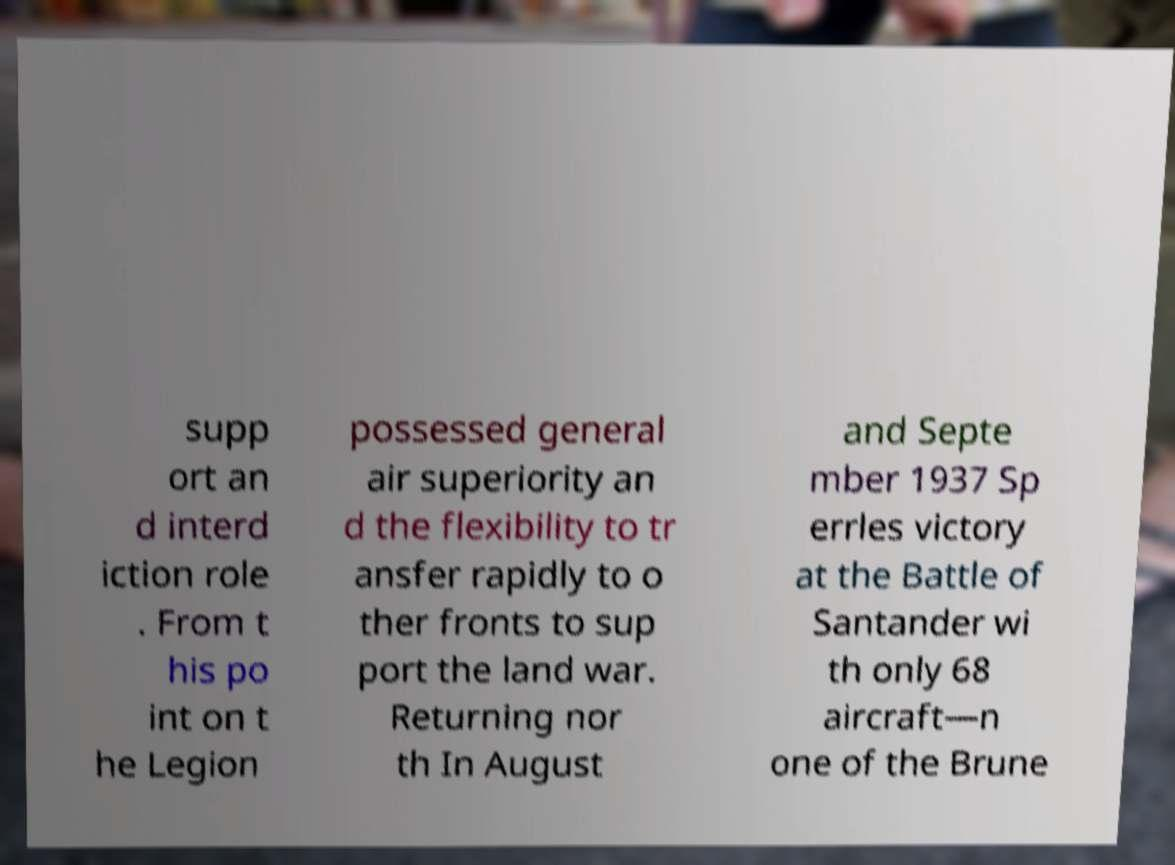Please identify and transcribe the text found in this image. supp ort an d interd iction role . From t his po int on t he Legion possessed general air superiority an d the flexibility to tr ansfer rapidly to o ther fronts to sup port the land war. Returning nor th In August and Septe mber 1937 Sp errles victory at the Battle of Santander wi th only 68 aircraft—n one of the Brune 